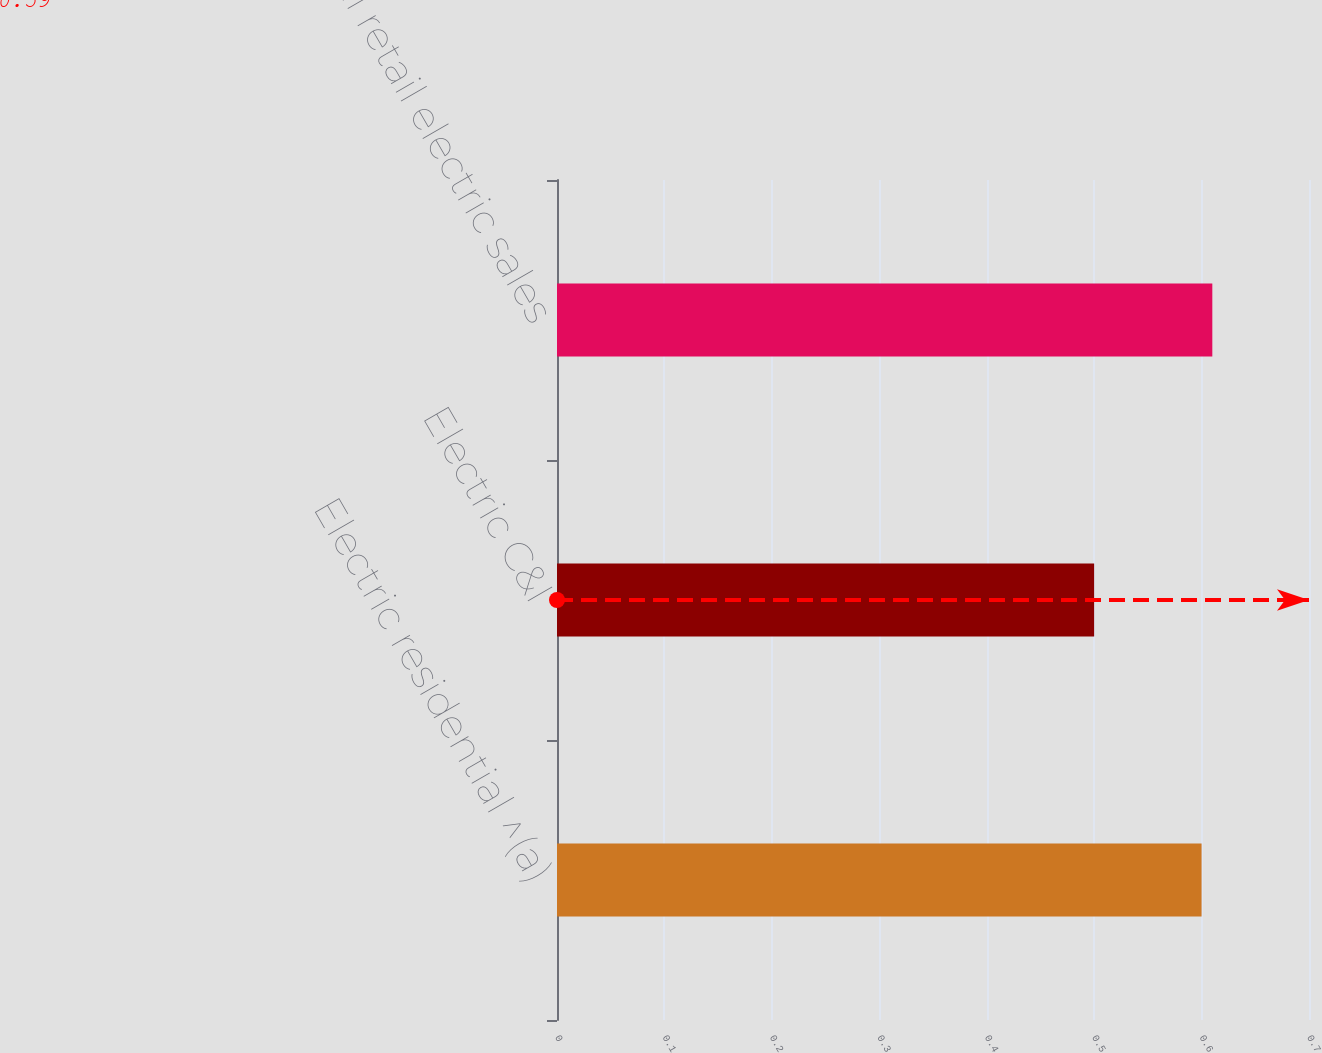Convert chart. <chart><loc_0><loc_0><loc_500><loc_500><bar_chart><fcel>Electric residential ^(a)<fcel>Electric C&I<fcel>Total retail electric sales<nl><fcel>0.6<fcel>0.5<fcel>0.61<nl></chart> 